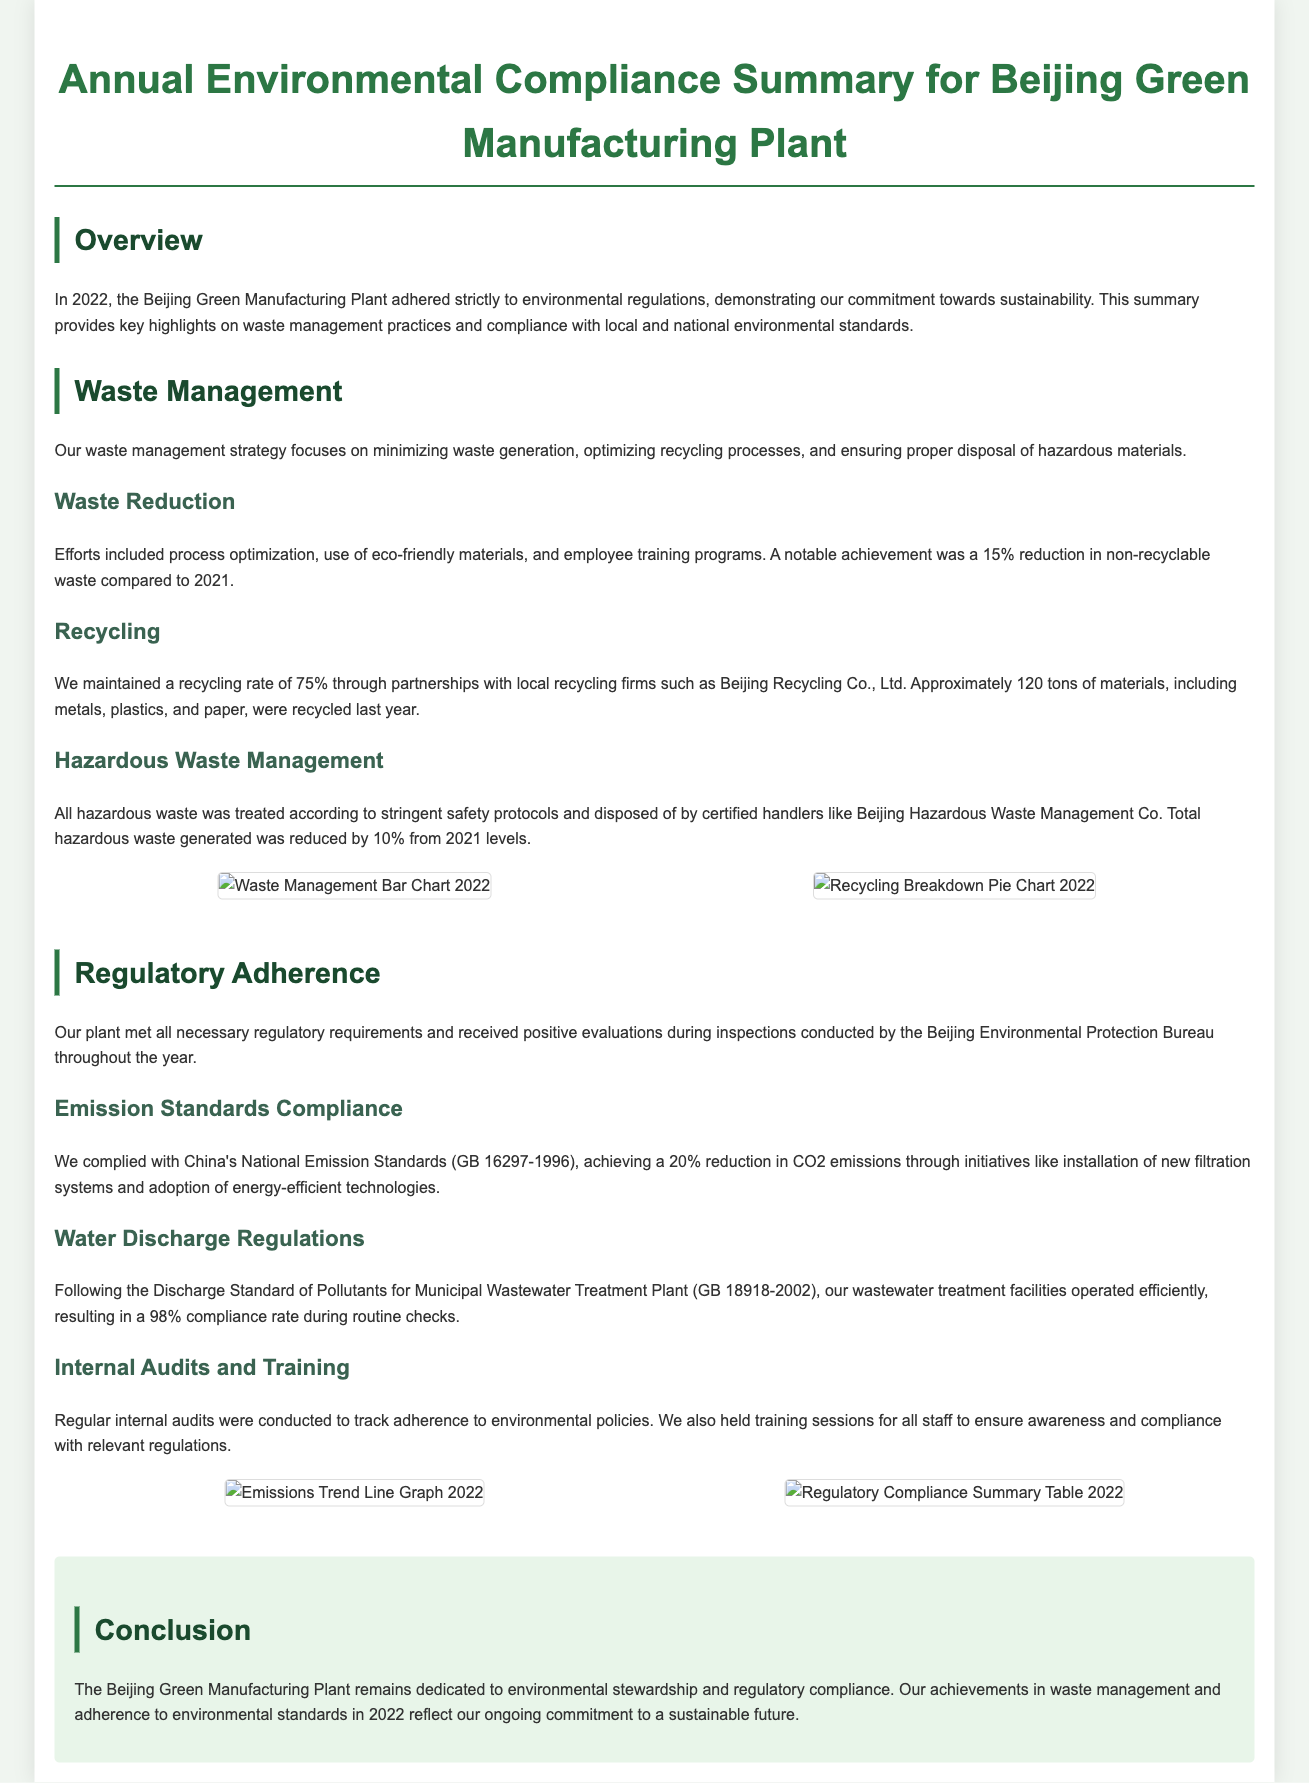What was the percentage reduction in non-recyclable waste in 2022? The document states that there was a 15% reduction in non-recyclable waste compared to 2021.
Answer: 15% What was the recycling rate maintained in 2022? According to the document, the recycling rate was maintained at 75%.
Answer: 75% How many tons of materials were recycled last year? The document mentions that approximately 120 tons of materials were recycled.
Answer: 120 tons What percentage of compliance was achieved for water discharge regulations? The document indicates that there was a 98% compliance rate during routine checks.
Answer: 98% How much was the reduction in hazardous waste generated compared to 2021 levels? The document states that total hazardous waste generated was reduced by 10% from 2021 levels.
Answer: 10% What is the name of the local recycling firm mentioned in the document? The document refers to a partnership with Beijing Recycling Co., Ltd.
Answer: Beijing Recycling Co., Ltd What significant technology implementation contributed to CO2 emissions reduction? The document highlights the installation of new filtration systems as a key initiative for emissions reduction.
Answer: filtration systems What is the title of the document? The title of the document provides an overview of its content as "Annual Environmental Compliance Summary for Beijing Green Manufacturing Plant."
Answer: Annual Environmental Compliance Summary for Beijing Green Manufacturing Plant What type of document is this? The document is an Annual Environmental Compliance Summary, focusing on waste management and regulatory adherence for a manufacturing plant.
Answer: Annual Environmental Compliance Summary 